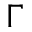<formula> <loc_0><loc_0><loc_500><loc_500>\Gamma</formula> 